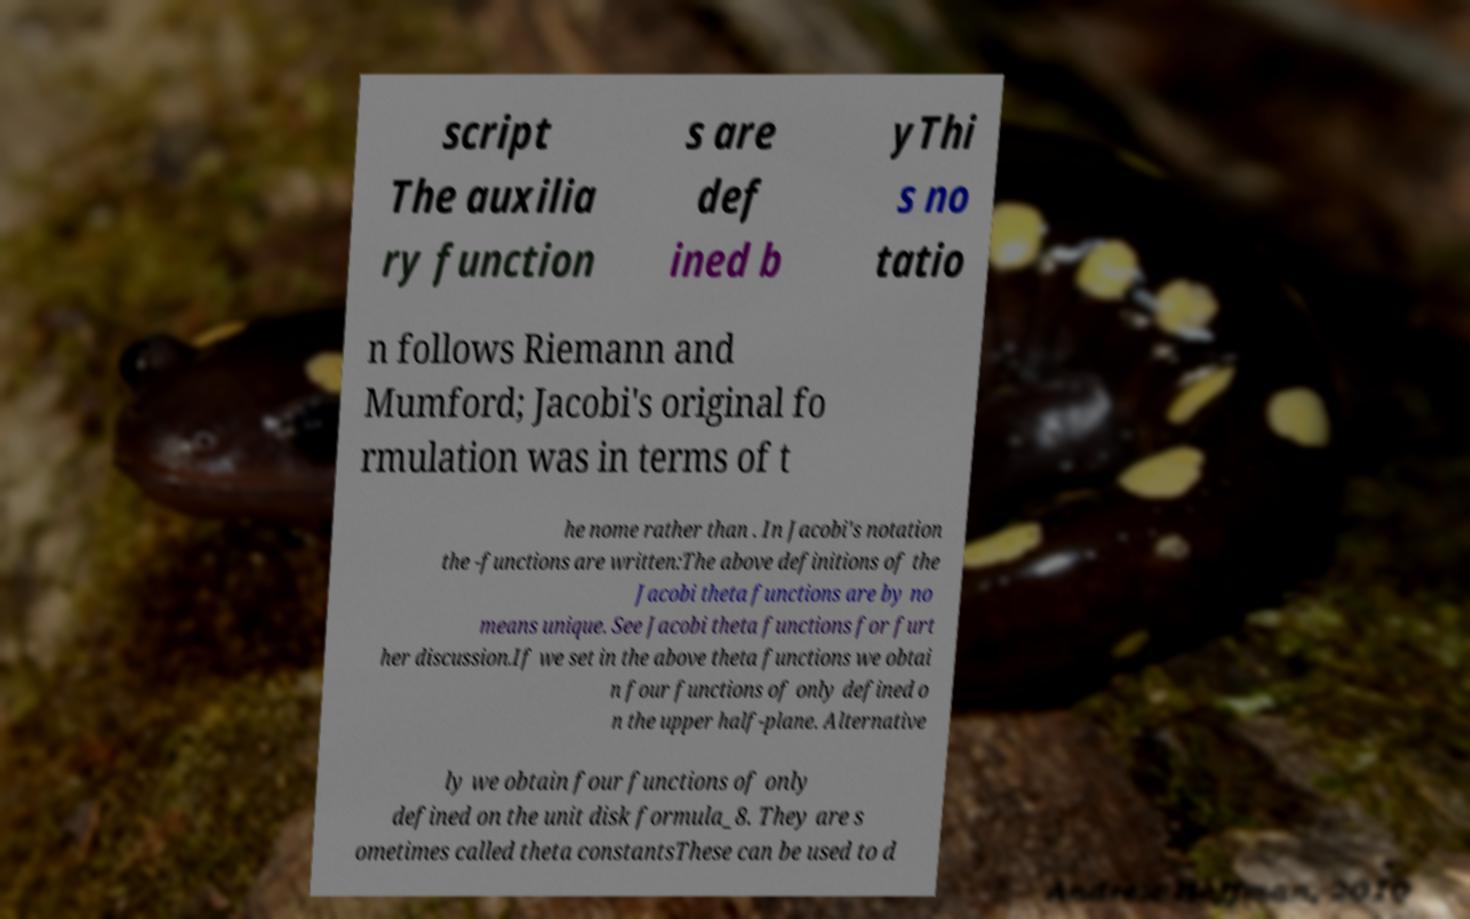Please identify and transcribe the text found in this image. script The auxilia ry function s are def ined b yThi s no tatio n follows Riemann and Mumford; Jacobi's original fo rmulation was in terms of t he nome rather than . In Jacobi's notation the -functions are written:The above definitions of the Jacobi theta functions are by no means unique. See Jacobi theta functions for furt her discussion.If we set in the above theta functions we obtai n four functions of only defined o n the upper half-plane. Alternative ly we obtain four functions of only defined on the unit disk formula_8. They are s ometimes called theta constantsThese can be used to d 